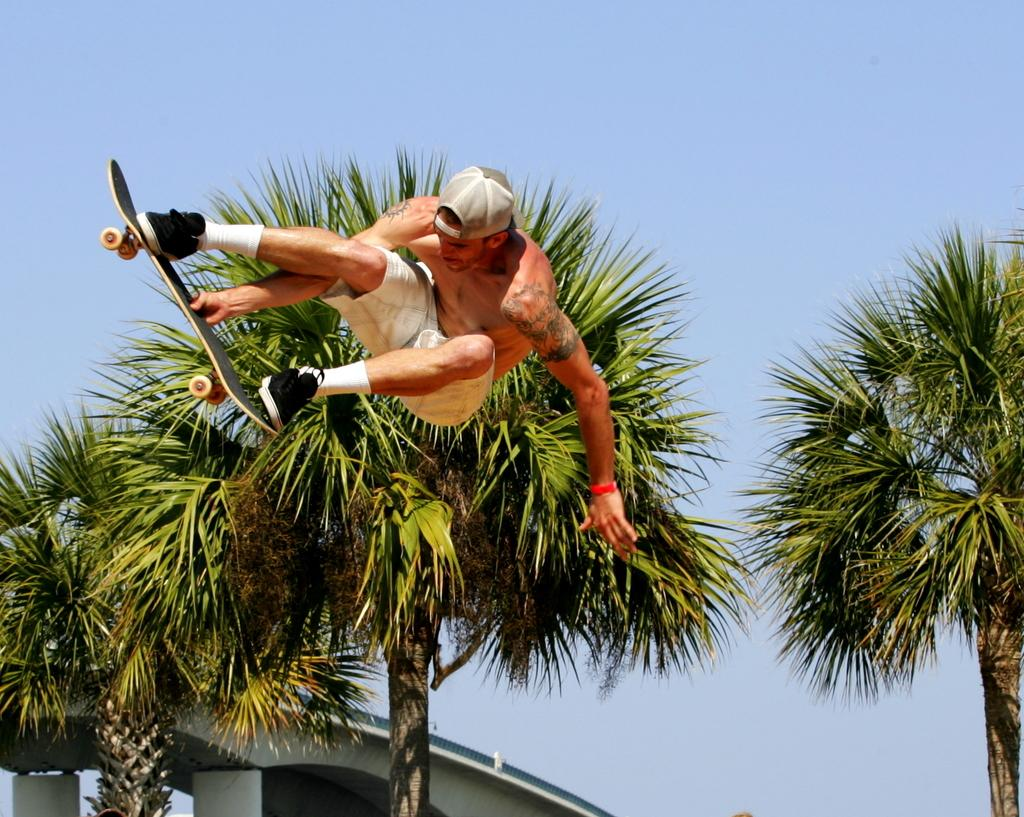What is the main subject of the image? There is a person in the image. What is the person doing in the image? The person is jumping on a ski board. What can be seen in the background of the image? The sky is visible in the image. Are there any other objects or elements in the image besides the person and the sky? Yes, there is a tree in the image. Where is the bag placed in the image? There is no bag present in the image. What type of range can be seen in the image? There is no range present in the image. 